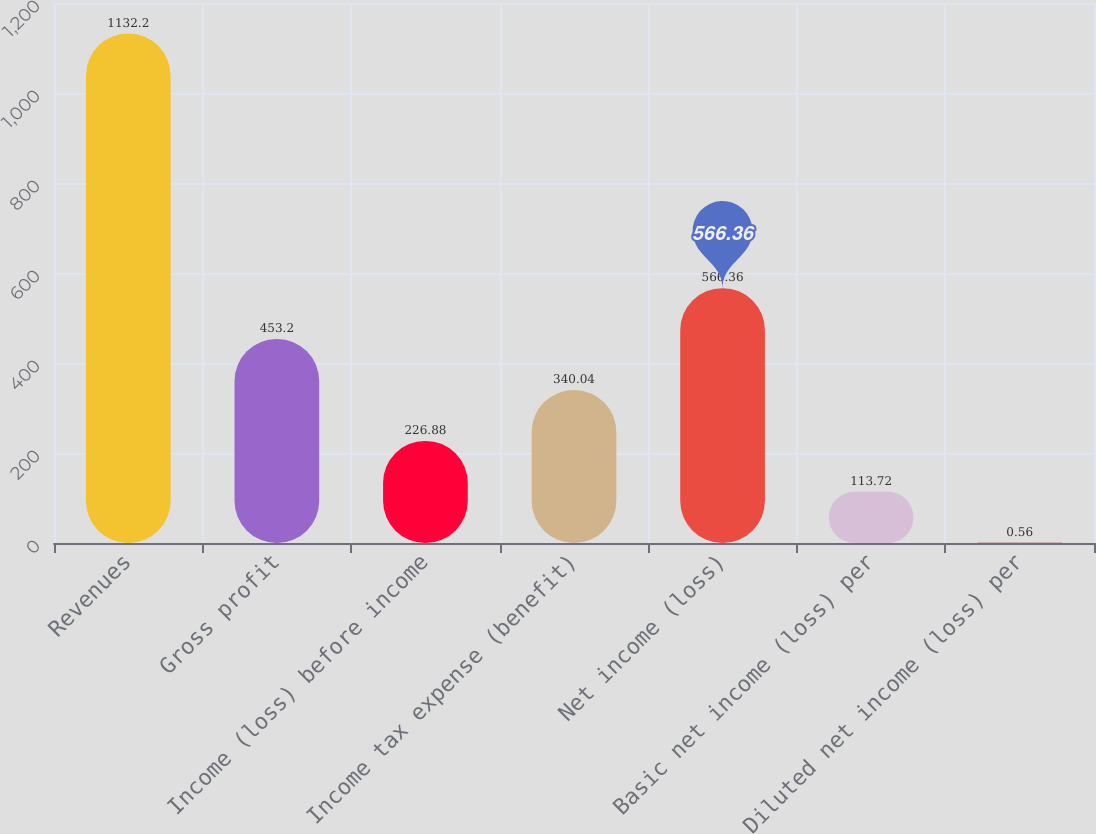Convert chart. <chart><loc_0><loc_0><loc_500><loc_500><bar_chart><fcel>Revenues<fcel>Gross profit<fcel>Income (loss) before income<fcel>Income tax expense (benefit)<fcel>Net income (loss)<fcel>Basic net income (loss) per<fcel>Diluted net income (loss) per<nl><fcel>1132.2<fcel>453.2<fcel>226.88<fcel>340.04<fcel>566.36<fcel>113.72<fcel>0.56<nl></chart> 